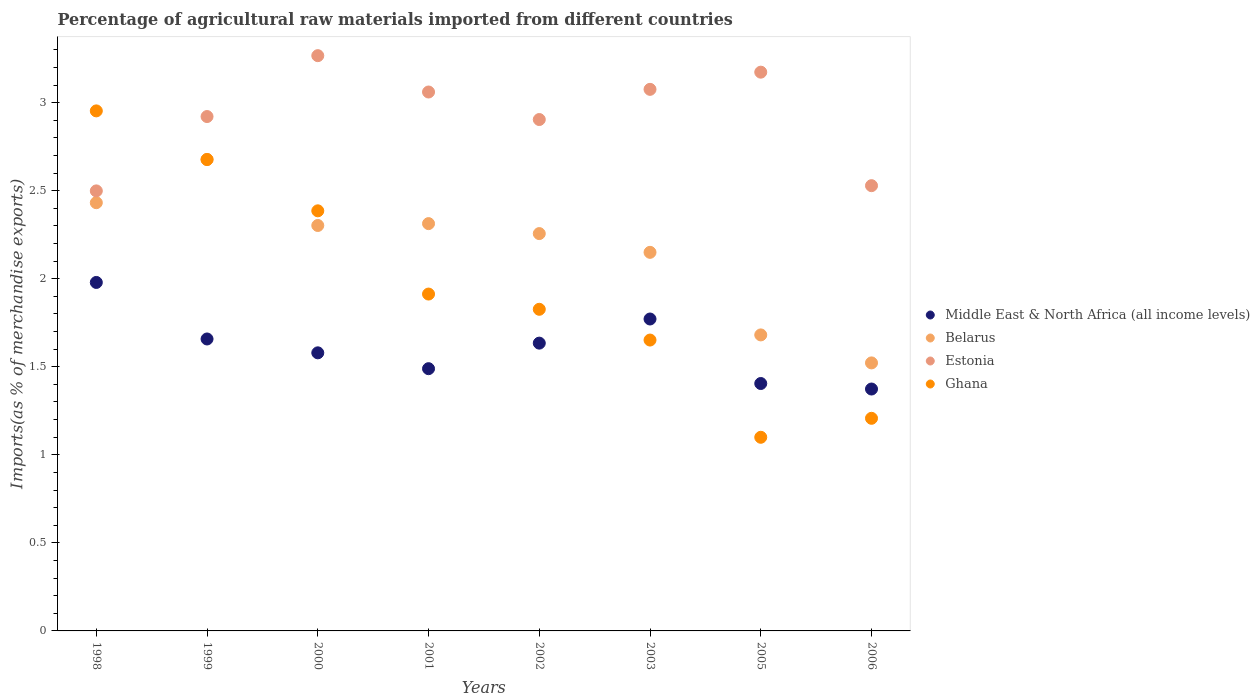How many different coloured dotlines are there?
Make the answer very short. 4. Is the number of dotlines equal to the number of legend labels?
Give a very brief answer. Yes. What is the percentage of imports to different countries in Ghana in 2001?
Keep it short and to the point. 1.91. Across all years, what is the maximum percentage of imports to different countries in Belarus?
Offer a terse response. 2.68. Across all years, what is the minimum percentage of imports to different countries in Estonia?
Make the answer very short. 2.5. In which year was the percentage of imports to different countries in Middle East & North Africa (all income levels) maximum?
Your response must be concise. 1998. In which year was the percentage of imports to different countries in Belarus minimum?
Give a very brief answer. 2006. What is the total percentage of imports to different countries in Ghana in the graph?
Ensure brevity in your answer.  15.71. What is the difference between the percentage of imports to different countries in Middle East & North Africa (all income levels) in 1998 and that in 2003?
Give a very brief answer. 0.21. What is the difference between the percentage of imports to different countries in Middle East & North Africa (all income levels) in 1999 and the percentage of imports to different countries in Ghana in 2000?
Make the answer very short. -0.73. What is the average percentage of imports to different countries in Belarus per year?
Provide a succinct answer. 2.17. In the year 2002, what is the difference between the percentage of imports to different countries in Ghana and percentage of imports to different countries in Estonia?
Your answer should be compact. -1.08. What is the ratio of the percentage of imports to different countries in Belarus in 2003 to that in 2006?
Offer a terse response. 1.41. What is the difference between the highest and the second highest percentage of imports to different countries in Ghana?
Provide a short and direct response. 0.28. What is the difference between the highest and the lowest percentage of imports to different countries in Belarus?
Your response must be concise. 1.16. In how many years, is the percentage of imports to different countries in Ghana greater than the average percentage of imports to different countries in Ghana taken over all years?
Your answer should be very brief. 3. Is the percentage of imports to different countries in Estonia strictly greater than the percentage of imports to different countries in Ghana over the years?
Make the answer very short. No. Is the percentage of imports to different countries in Belarus strictly less than the percentage of imports to different countries in Ghana over the years?
Your response must be concise. No. How many dotlines are there?
Your response must be concise. 4. What is the difference between two consecutive major ticks on the Y-axis?
Your answer should be compact. 0.5. Are the values on the major ticks of Y-axis written in scientific E-notation?
Provide a succinct answer. No. Where does the legend appear in the graph?
Give a very brief answer. Center right. What is the title of the graph?
Keep it short and to the point. Percentage of agricultural raw materials imported from different countries. Does "Oman" appear as one of the legend labels in the graph?
Your answer should be very brief. No. What is the label or title of the X-axis?
Provide a short and direct response. Years. What is the label or title of the Y-axis?
Offer a very short reply. Imports(as % of merchandise exports). What is the Imports(as % of merchandise exports) in Middle East & North Africa (all income levels) in 1998?
Offer a terse response. 1.98. What is the Imports(as % of merchandise exports) of Belarus in 1998?
Your answer should be very brief. 2.43. What is the Imports(as % of merchandise exports) in Estonia in 1998?
Offer a terse response. 2.5. What is the Imports(as % of merchandise exports) of Ghana in 1998?
Your answer should be very brief. 2.95. What is the Imports(as % of merchandise exports) in Middle East & North Africa (all income levels) in 1999?
Ensure brevity in your answer.  1.66. What is the Imports(as % of merchandise exports) in Belarus in 1999?
Make the answer very short. 2.68. What is the Imports(as % of merchandise exports) of Estonia in 1999?
Your answer should be compact. 2.92. What is the Imports(as % of merchandise exports) in Ghana in 1999?
Ensure brevity in your answer.  2.68. What is the Imports(as % of merchandise exports) in Middle East & North Africa (all income levels) in 2000?
Offer a terse response. 1.58. What is the Imports(as % of merchandise exports) in Belarus in 2000?
Your answer should be compact. 2.3. What is the Imports(as % of merchandise exports) of Estonia in 2000?
Your answer should be compact. 3.27. What is the Imports(as % of merchandise exports) in Ghana in 2000?
Keep it short and to the point. 2.39. What is the Imports(as % of merchandise exports) in Middle East & North Africa (all income levels) in 2001?
Provide a short and direct response. 1.49. What is the Imports(as % of merchandise exports) of Belarus in 2001?
Provide a succinct answer. 2.31. What is the Imports(as % of merchandise exports) in Estonia in 2001?
Make the answer very short. 3.06. What is the Imports(as % of merchandise exports) in Ghana in 2001?
Your response must be concise. 1.91. What is the Imports(as % of merchandise exports) in Middle East & North Africa (all income levels) in 2002?
Ensure brevity in your answer.  1.63. What is the Imports(as % of merchandise exports) of Belarus in 2002?
Keep it short and to the point. 2.26. What is the Imports(as % of merchandise exports) in Estonia in 2002?
Your answer should be compact. 2.9. What is the Imports(as % of merchandise exports) of Ghana in 2002?
Your response must be concise. 1.83. What is the Imports(as % of merchandise exports) of Middle East & North Africa (all income levels) in 2003?
Offer a very short reply. 1.77. What is the Imports(as % of merchandise exports) in Belarus in 2003?
Keep it short and to the point. 2.15. What is the Imports(as % of merchandise exports) in Estonia in 2003?
Ensure brevity in your answer.  3.08. What is the Imports(as % of merchandise exports) in Ghana in 2003?
Give a very brief answer. 1.65. What is the Imports(as % of merchandise exports) of Middle East & North Africa (all income levels) in 2005?
Provide a succinct answer. 1.4. What is the Imports(as % of merchandise exports) in Belarus in 2005?
Offer a terse response. 1.68. What is the Imports(as % of merchandise exports) of Estonia in 2005?
Your answer should be compact. 3.17. What is the Imports(as % of merchandise exports) of Ghana in 2005?
Keep it short and to the point. 1.1. What is the Imports(as % of merchandise exports) of Middle East & North Africa (all income levels) in 2006?
Ensure brevity in your answer.  1.37. What is the Imports(as % of merchandise exports) in Belarus in 2006?
Your response must be concise. 1.52. What is the Imports(as % of merchandise exports) of Estonia in 2006?
Your answer should be very brief. 2.53. What is the Imports(as % of merchandise exports) in Ghana in 2006?
Your answer should be very brief. 1.21. Across all years, what is the maximum Imports(as % of merchandise exports) in Middle East & North Africa (all income levels)?
Your answer should be very brief. 1.98. Across all years, what is the maximum Imports(as % of merchandise exports) in Belarus?
Make the answer very short. 2.68. Across all years, what is the maximum Imports(as % of merchandise exports) in Estonia?
Provide a short and direct response. 3.27. Across all years, what is the maximum Imports(as % of merchandise exports) of Ghana?
Make the answer very short. 2.95. Across all years, what is the minimum Imports(as % of merchandise exports) in Middle East & North Africa (all income levels)?
Your response must be concise. 1.37. Across all years, what is the minimum Imports(as % of merchandise exports) of Belarus?
Give a very brief answer. 1.52. Across all years, what is the minimum Imports(as % of merchandise exports) in Estonia?
Keep it short and to the point. 2.5. Across all years, what is the minimum Imports(as % of merchandise exports) of Ghana?
Ensure brevity in your answer.  1.1. What is the total Imports(as % of merchandise exports) of Middle East & North Africa (all income levels) in the graph?
Make the answer very short. 12.89. What is the total Imports(as % of merchandise exports) in Belarus in the graph?
Your answer should be very brief. 17.33. What is the total Imports(as % of merchandise exports) of Estonia in the graph?
Offer a very short reply. 23.43. What is the total Imports(as % of merchandise exports) in Ghana in the graph?
Your response must be concise. 15.71. What is the difference between the Imports(as % of merchandise exports) in Middle East & North Africa (all income levels) in 1998 and that in 1999?
Offer a very short reply. 0.32. What is the difference between the Imports(as % of merchandise exports) in Belarus in 1998 and that in 1999?
Provide a short and direct response. -0.25. What is the difference between the Imports(as % of merchandise exports) of Estonia in 1998 and that in 1999?
Your answer should be compact. -0.42. What is the difference between the Imports(as % of merchandise exports) of Ghana in 1998 and that in 1999?
Your answer should be compact. 0.28. What is the difference between the Imports(as % of merchandise exports) of Middle East & North Africa (all income levels) in 1998 and that in 2000?
Your answer should be very brief. 0.4. What is the difference between the Imports(as % of merchandise exports) in Belarus in 1998 and that in 2000?
Offer a very short reply. 0.13. What is the difference between the Imports(as % of merchandise exports) in Estonia in 1998 and that in 2000?
Your answer should be very brief. -0.77. What is the difference between the Imports(as % of merchandise exports) in Ghana in 1998 and that in 2000?
Give a very brief answer. 0.57. What is the difference between the Imports(as % of merchandise exports) in Middle East & North Africa (all income levels) in 1998 and that in 2001?
Provide a short and direct response. 0.49. What is the difference between the Imports(as % of merchandise exports) of Belarus in 1998 and that in 2001?
Your response must be concise. 0.12. What is the difference between the Imports(as % of merchandise exports) in Estonia in 1998 and that in 2001?
Your answer should be compact. -0.56. What is the difference between the Imports(as % of merchandise exports) in Ghana in 1998 and that in 2001?
Ensure brevity in your answer.  1.04. What is the difference between the Imports(as % of merchandise exports) of Middle East & North Africa (all income levels) in 1998 and that in 2002?
Make the answer very short. 0.34. What is the difference between the Imports(as % of merchandise exports) in Belarus in 1998 and that in 2002?
Provide a short and direct response. 0.18. What is the difference between the Imports(as % of merchandise exports) in Estonia in 1998 and that in 2002?
Provide a succinct answer. -0.41. What is the difference between the Imports(as % of merchandise exports) of Ghana in 1998 and that in 2002?
Your response must be concise. 1.13. What is the difference between the Imports(as % of merchandise exports) in Middle East & North Africa (all income levels) in 1998 and that in 2003?
Provide a short and direct response. 0.21. What is the difference between the Imports(as % of merchandise exports) in Belarus in 1998 and that in 2003?
Keep it short and to the point. 0.28. What is the difference between the Imports(as % of merchandise exports) of Estonia in 1998 and that in 2003?
Your answer should be compact. -0.58. What is the difference between the Imports(as % of merchandise exports) in Ghana in 1998 and that in 2003?
Your answer should be very brief. 1.3. What is the difference between the Imports(as % of merchandise exports) of Middle East & North Africa (all income levels) in 1998 and that in 2005?
Provide a succinct answer. 0.57. What is the difference between the Imports(as % of merchandise exports) of Belarus in 1998 and that in 2005?
Ensure brevity in your answer.  0.75. What is the difference between the Imports(as % of merchandise exports) in Estonia in 1998 and that in 2005?
Your answer should be compact. -0.67. What is the difference between the Imports(as % of merchandise exports) in Ghana in 1998 and that in 2005?
Your response must be concise. 1.85. What is the difference between the Imports(as % of merchandise exports) of Middle East & North Africa (all income levels) in 1998 and that in 2006?
Give a very brief answer. 0.61. What is the difference between the Imports(as % of merchandise exports) of Belarus in 1998 and that in 2006?
Give a very brief answer. 0.91. What is the difference between the Imports(as % of merchandise exports) of Estonia in 1998 and that in 2006?
Offer a very short reply. -0.03. What is the difference between the Imports(as % of merchandise exports) of Ghana in 1998 and that in 2006?
Ensure brevity in your answer.  1.75. What is the difference between the Imports(as % of merchandise exports) of Middle East & North Africa (all income levels) in 1999 and that in 2000?
Give a very brief answer. 0.08. What is the difference between the Imports(as % of merchandise exports) in Belarus in 1999 and that in 2000?
Give a very brief answer. 0.38. What is the difference between the Imports(as % of merchandise exports) in Estonia in 1999 and that in 2000?
Make the answer very short. -0.35. What is the difference between the Imports(as % of merchandise exports) of Ghana in 1999 and that in 2000?
Keep it short and to the point. 0.29. What is the difference between the Imports(as % of merchandise exports) of Middle East & North Africa (all income levels) in 1999 and that in 2001?
Offer a very short reply. 0.17. What is the difference between the Imports(as % of merchandise exports) in Belarus in 1999 and that in 2001?
Make the answer very short. 0.36. What is the difference between the Imports(as % of merchandise exports) in Estonia in 1999 and that in 2001?
Your response must be concise. -0.14. What is the difference between the Imports(as % of merchandise exports) in Ghana in 1999 and that in 2001?
Keep it short and to the point. 0.76. What is the difference between the Imports(as % of merchandise exports) in Middle East & North Africa (all income levels) in 1999 and that in 2002?
Your answer should be compact. 0.02. What is the difference between the Imports(as % of merchandise exports) in Belarus in 1999 and that in 2002?
Make the answer very short. 0.42. What is the difference between the Imports(as % of merchandise exports) of Estonia in 1999 and that in 2002?
Your answer should be very brief. 0.02. What is the difference between the Imports(as % of merchandise exports) in Ghana in 1999 and that in 2002?
Your answer should be compact. 0.85. What is the difference between the Imports(as % of merchandise exports) of Middle East & North Africa (all income levels) in 1999 and that in 2003?
Offer a terse response. -0.11. What is the difference between the Imports(as % of merchandise exports) of Belarus in 1999 and that in 2003?
Provide a short and direct response. 0.53. What is the difference between the Imports(as % of merchandise exports) in Estonia in 1999 and that in 2003?
Make the answer very short. -0.15. What is the difference between the Imports(as % of merchandise exports) of Ghana in 1999 and that in 2003?
Give a very brief answer. 1.03. What is the difference between the Imports(as % of merchandise exports) in Middle East & North Africa (all income levels) in 1999 and that in 2005?
Make the answer very short. 0.25. What is the difference between the Imports(as % of merchandise exports) of Estonia in 1999 and that in 2005?
Offer a very short reply. -0.25. What is the difference between the Imports(as % of merchandise exports) in Ghana in 1999 and that in 2005?
Ensure brevity in your answer.  1.58. What is the difference between the Imports(as % of merchandise exports) in Middle East & North Africa (all income levels) in 1999 and that in 2006?
Provide a short and direct response. 0.28. What is the difference between the Imports(as % of merchandise exports) of Belarus in 1999 and that in 2006?
Make the answer very short. 1.16. What is the difference between the Imports(as % of merchandise exports) in Estonia in 1999 and that in 2006?
Provide a short and direct response. 0.39. What is the difference between the Imports(as % of merchandise exports) in Ghana in 1999 and that in 2006?
Give a very brief answer. 1.47. What is the difference between the Imports(as % of merchandise exports) in Middle East & North Africa (all income levels) in 2000 and that in 2001?
Offer a terse response. 0.09. What is the difference between the Imports(as % of merchandise exports) in Belarus in 2000 and that in 2001?
Provide a succinct answer. -0.01. What is the difference between the Imports(as % of merchandise exports) of Estonia in 2000 and that in 2001?
Your answer should be compact. 0.21. What is the difference between the Imports(as % of merchandise exports) in Ghana in 2000 and that in 2001?
Offer a terse response. 0.47. What is the difference between the Imports(as % of merchandise exports) of Middle East & North Africa (all income levels) in 2000 and that in 2002?
Offer a terse response. -0.06. What is the difference between the Imports(as % of merchandise exports) in Belarus in 2000 and that in 2002?
Make the answer very short. 0.05. What is the difference between the Imports(as % of merchandise exports) of Estonia in 2000 and that in 2002?
Offer a terse response. 0.36. What is the difference between the Imports(as % of merchandise exports) in Ghana in 2000 and that in 2002?
Your answer should be compact. 0.56. What is the difference between the Imports(as % of merchandise exports) in Middle East & North Africa (all income levels) in 2000 and that in 2003?
Your answer should be very brief. -0.19. What is the difference between the Imports(as % of merchandise exports) of Belarus in 2000 and that in 2003?
Make the answer very short. 0.15. What is the difference between the Imports(as % of merchandise exports) in Estonia in 2000 and that in 2003?
Provide a succinct answer. 0.19. What is the difference between the Imports(as % of merchandise exports) in Ghana in 2000 and that in 2003?
Provide a succinct answer. 0.73. What is the difference between the Imports(as % of merchandise exports) in Middle East & North Africa (all income levels) in 2000 and that in 2005?
Ensure brevity in your answer.  0.17. What is the difference between the Imports(as % of merchandise exports) of Belarus in 2000 and that in 2005?
Offer a terse response. 0.62. What is the difference between the Imports(as % of merchandise exports) of Estonia in 2000 and that in 2005?
Your answer should be compact. 0.09. What is the difference between the Imports(as % of merchandise exports) in Ghana in 2000 and that in 2005?
Your answer should be compact. 1.29. What is the difference between the Imports(as % of merchandise exports) in Middle East & North Africa (all income levels) in 2000 and that in 2006?
Offer a terse response. 0.21. What is the difference between the Imports(as % of merchandise exports) of Belarus in 2000 and that in 2006?
Ensure brevity in your answer.  0.78. What is the difference between the Imports(as % of merchandise exports) of Estonia in 2000 and that in 2006?
Offer a terse response. 0.74. What is the difference between the Imports(as % of merchandise exports) in Ghana in 2000 and that in 2006?
Offer a terse response. 1.18. What is the difference between the Imports(as % of merchandise exports) in Middle East & North Africa (all income levels) in 2001 and that in 2002?
Offer a terse response. -0.15. What is the difference between the Imports(as % of merchandise exports) of Belarus in 2001 and that in 2002?
Offer a terse response. 0.06. What is the difference between the Imports(as % of merchandise exports) in Estonia in 2001 and that in 2002?
Your answer should be compact. 0.16. What is the difference between the Imports(as % of merchandise exports) in Ghana in 2001 and that in 2002?
Your answer should be compact. 0.09. What is the difference between the Imports(as % of merchandise exports) of Middle East & North Africa (all income levels) in 2001 and that in 2003?
Your answer should be compact. -0.28. What is the difference between the Imports(as % of merchandise exports) in Belarus in 2001 and that in 2003?
Your answer should be compact. 0.16. What is the difference between the Imports(as % of merchandise exports) in Estonia in 2001 and that in 2003?
Your answer should be compact. -0.02. What is the difference between the Imports(as % of merchandise exports) in Ghana in 2001 and that in 2003?
Make the answer very short. 0.26. What is the difference between the Imports(as % of merchandise exports) of Middle East & North Africa (all income levels) in 2001 and that in 2005?
Ensure brevity in your answer.  0.08. What is the difference between the Imports(as % of merchandise exports) in Belarus in 2001 and that in 2005?
Your answer should be compact. 0.63. What is the difference between the Imports(as % of merchandise exports) of Estonia in 2001 and that in 2005?
Offer a terse response. -0.11. What is the difference between the Imports(as % of merchandise exports) in Ghana in 2001 and that in 2005?
Offer a terse response. 0.81. What is the difference between the Imports(as % of merchandise exports) in Middle East & North Africa (all income levels) in 2001 and that in 2006?
Make the answer very short. 0.12. What is the difference between the Imports(as % of merchandise exports) of Belarus in 2001 and that in 2006?
Make the answer very short. 0.79. What is the difference between the Imports(as % of merchandise exports) in Estonia in 2001 and that in 2006?
Your response must be concise. 0.53. What is the difference between the Imports(as % of merchandise exports) of Ghana in 2001 and that in 2006?
Your answer should be very brief. 0.71. What is the difference between the Imports(as % of merchandise exports) of Middle East & North Africa (all income levels) in 2002 and that in 2003?
Provide a short and direct response. -0.14. What is the difference between the Imports(as % of merchandise exports) in Belarus in 2002 and that in 2003?
Your answer should be very brief. 0.11. What is the difference between the Imports(as % of merchandise exports) in Estonia in 2002 and that in 2003?
Make the answer very short. -0.17. What is the difference between the Imports(as % of merchandise exports) of Ghana in 2002 and that in 2003?
Offer a terse response. 0.17. What is the difference between the Imports(as % of merchandise exports) of Middle East & North Africa (all income levels) in 2002 and that in 2005?
Provide a short and direct response. 0.23. What is the difference between the Imports(as % of merchandise exports) in Belarus in 2002 and that in 2005?
Your answer should be compact. 0.58. What is the difference between the Imports(as % of merchandise exports) in Estonia in 2002 and that in 2005?
Your response must be concise. -0.27. What is the difference between the Imports(as % of merchandise exports) in Ghana in 2002 and that in 2005?
Your answer should be very brief. 0.73. What is the difference between the Imports(as % of merchandise exports) in Middle East & North Africa (all income levels) in 2002 and that in 2006?
Offer a terse response. 0.26. What is the difference between the Imports(as % of merchandise exports) in Belarus in 2002 and that in 2006?
Your response must be concise. 0.73. What is the difference between the Imports(as % of merchandise exports) in Estonia in 2002 and that in 2006?
Your answer should be very brief. 0.38. What is the difference between the Imports(as % of merchandise exports) in Ghana in 2002 and that in 2006?
Your answer should be compact. 0.62. What is the difference between the Imports(as % of merchandise exports) of Middle East & North Africa (all income levels) in 2003 and that in 2005?
Ensure brevity in your answer.  0.37. What is the difference between the Imports(as % of merchandise exports) in Belarus in 2003 and that in 2005?
Your response must be concise. 0.47. What is the difference between the Imports(as % of merchandise exports) of Estonia in 2003 and that in 2005?
Provide a succinct answer. -0.1. What is the difference between the Imports(as % of merchandise exports) in Ghana in 2003 and that in 2005?
Offer a terse response. 0.55. What is the difference between the Imports(as % of merchandise exports) in Middle East & North Africa (all income levels) in 2003 and that in 2006?
Your response must be concise. 0.4. What is the difference between the Imports(as % of merchandise exports) of Belarus in 2003 and that in 2006?
Your answer should be very brief. 0.63. What is the difference between the Imports(as % of merchandise exports) in Estonia in 2003 and that in 2006?
Offer a terse response. 0.55. What is the difference between the Imports(as % of merchandise exports) in Ghana in 2003 and that in 2006?
Offer a very short reply. 0.44. What is the difference between the Imports(as % of merchandise exports) in Middle East & North Africa (all income levels) in 2005 and that in 2006?
Your answer should be very brief. 0.03. What is the difference between the Imports(as % of merchandise exports) in Belarus in 2005 and that in 2006?
Your response must be concise. 0.16. What is the difference between the Imports(as % of merchandise exports) of Estonia in 2005 and that in 2006?
Provide a short and direct response. 0.64. What is the difference between the Imports(as % of merchandise exports) in Ghana in 2005 and that in 2006?
Your answer should be very brief. -0.11. What is the difference between the Imports(as % of merchandise exports) of Middle East & North Africa (all income levels) in 1998 and the Imports(as % of merchandise exports) of Belarus in 1999?
Keep it short and to the point. -0.7. What is the difference between the Imports(as % of merchandise exports) in Middle East & North Africa (all income levels) in 1998 and the Imports(as % of merchandise exports) in Estonia in 1999?
Provide a succinct answer. -0.94. What is the difference between the Imports(as % of merchandise exports) of Middle East & North Africa (all income levels) in 1998 and the Imports(as % of merchandise exports) of Ghana in 1999?
Ensure brevity in your answer.  -0.7. What is the difference between the Imports(as % of merchandise exports) of Belarus in 1998 and the Imports(as % of merchandise exports) of Estonia in 1999?
Ensure brevity in your answer.  -0.49. What is the difference between the Imports(as % of merchandise exports) of Belarus in 1998 and the Imports(as % of merchandise exports) of Ghana in 1999?
Make the answer very short. -0.25. What is the difference between the Imports(as % of merchandise exports) in Estonia in 1998 and the Imports(as % of merchandise exports) in Ghana in 1999?
Your answer should be compact. -0.18. What is the difference between the Imports(as % of merchandise exports) in Middle East & North Africa (all income levels) in 1998 and the Imports(as % of merchandise exports) in Belarus in 2000?
Keep it short and to the point. -0.32. What is the difference between the Imports(as % of merchandise exports) in Middle East & North Africa (all income levels) in 1998 and the Imports(as % of merchandise exports) in Estonia in 2000?
Ensure brevity in your answer.  -1.29. What is the difference between the Imports(as % of merchandise exports) of Middle East & North Africa (all income levels) in 1998 and the Imports(as % of merchandise exports) of Ghana in 2000?
Your answer should be compact. -0.41. What is the difference between the Imports(as % of merchandise exports) in Belarus in 1998 and the Imports(as % of merchandise exports) in Estonia in 2000?
Give a very brief answer. -0.83. What is the difference between the Imports(as % of merchandise exports) in Belarus in 1998 and the Imports(as % of merchandise exports) in Ghana in 2000?
Your answer should be compact. 0.05. What is the difference between the Imports(as % of merchandise exports) of Estonia in 1998 and the Imports(as % of merchandise exports) of Ghana in 2000?
Give a very brief answer. 0.11. What is the difference between the Imports(as % of merchandise exports) of Middle East & North Africa (all income levels) in 1998 and the Imports(as % of merchandise exports) of Belarus in 2001?
Make the answer very short. -0.33. What is the difference between the Imports(as % of merchandise exports) of Middle East & North Africa (all income levels) in 1998 and the Imports(as % of merchandise exports) of Estonia in 2001?
Your answer should be very brief. -1.08. What is the difference between the Imports(as % of merchandise exports) in Middle East & North Africa (all income levels) in 1998 and the Imports(as % of merchandise exports) in Ghana in 2001?
Give a very brief answer. 0.07. What is the difference between the Imports(as % of merchandise exports) in Belarus in 1998 and the Imports(as % of merchandise exports) in Estonia in 2001?
Offer a very short reply. -0.63. What is the difference between the Imports(as % of merchandise exports) in Belarus in 1998 and the Imports(as % of merchandise exports) in Ghana in 2001?
Ensure brevity in your answer.  0.52. What is the difference between the Imports(as % of merchandise exports) of Estonia in 1998 and the Imports(as % of merchandise exports) of Ghana in 2001?
Offer a very short reply. 0.59. What is the difference between the Imports(as % of merchandise exports) of Middle East & North Africa (all income levels) in 1998 and the Imports(as % of merchandise exports) of Belarus in 2002?
Ensure brevity in your answer.  -0.28. What is the difference between the Imports(as % of merchandise exports) in Middle East & North Africa (all income levels) in 1998 and the Imports(as % of merchandise exports) in Estonia in 2002?
Your answer should be compact. -0.93. What is the difference between the Imports(as % of merchandise exports) of Middle East & North Africa (all income levels) in 1998 and the Imports(as % of merchandise exports) of Ghana in 2002?
Offer a terse response. 0.15. What is the difference between the Imports(as % of merchandise exports) of Belarus in 1998 and the Imports(as % of merchandise exports) of Estonia in 2002?
Your response must be concise. -0.47. What is the difference between the Imports(as % of merchandise exports) in Belarus in 1998 and the Imports(as % of merchandise exports) in Ghana in 2002?
Provide a succinct answer. 0.61. What is the difference between the Imports(as % of merchandise exports) in Estonia in 1998 and the Imports(as % of merchandise exports) in Ghana in 2002?
Your answer should be very brief. 0.67. What is the difference between the Imports(as % of merchandise exports) in Middle East & North Africa (all income levels) in 1998 and the Imports(as % of merchandise exports) in Belarus in 2003?
Provide a short and direct response. -0.17. What is the difference between the Imports(as % of merchandise exports) in Middle East & North Africa (all income levels) in 1998 and the Imports(as % of merchandise exports) in Estonia in 2003?
Provide a succinct answer. -1.1. What is the difference between the Imports(as % of merchandise exports) of Middle East & North Africa (all income levels) in 1998 and the Imports(as % of merchandise exports) of Ghana in 2003?
Ensure brevity in your answer.  0.33. What is the difference between the Imports(as % of merchandise exports) of Belarus in 1998 and the Imports(as % of merchandise exports) of Estonia in 2003?
Provide a succinct answer. -0.64. What is the difference between the Imports(as % of merchandise exports) of Belarus in 1998 and the Imports(as % of merchandise exports) of Ghana in 2003?
Your answer should be compact. 0.78. What is the difference between the Imports(as % of merchandise exports) of Estonia in 1998 and the Imports(as % of merchandise exports) of Ghana in 2003?
Make the answer very short. 0.85. What is the difference between the Imports(as % of merchandise exports) in Middle East & North Africa (all income levels) in 1998 and the Imports(as % of merchandise exports) in Belarus in 2005?
Provide a succinct answer. 0.3. What is the difference between the Imports(as % of merchandise exports) of Middle East & North Africa (all income levels) in 1998 and the Imports(as % of merchandise exports) of Estonia in 2005?
Ensure brevity in your answer.  -1.19. What is the difference between the Imports(as % of merchandise exports) in Middle East & North Africa (all income levels) in 1998 and the Imports(as % of merchandise exports) in Ghana in 2005?
Keep it short and to the point. 0.88. What is the difference between the Imports(as % of merchandise exports) in Belarus in 1998 and the Imports(as % of merchandise exports) in Estonia in 2005?
Give a very brief answer. -0.74. What is the difference between the Imports(as % of merchandise exports) in Belarus in 1998 and the Imports(as % of merchandise exports) in Ghana in 2005?
Offer a very short reply. 1.33. What is the difference between the Imports(as % of merchandise exports) of Estonia in 1998 and the Imports(as % of merchandise exports) of Ghana in 2005?
Offer a terse response. 1.4. What is the difference between the Imports(as % of merchandise exports) of Middle East & North Africa (all income levels) in 1998 and the Imports(as % of merchandise exports) of Belarus in 2006?
Your answer should be compact. 0.46. What is the difference between the Imports(as % of merchandise exports) in Middle East & North Africa (all income levels) in 1998 and the Imports(as % of merchandise exports) in Estonia in 2006?
Offer a terse response. -0.55. What is the difference between the Imports(as % of merchandise exports) in Middle East & North Africa (all income levels) in 1998 and the Imports(as % of merchandise exports) in Ghana in 2006?
Keep it short and to the point. 0.77. What is the difference between the Imports(as % of merchandise exports) of Belarus in 1998 and the Imports(as % of merchandise exports) of Estonia in 2006?
Offer a very short reply. -0.1. What is the difference between the Imports(as % of merchandise exports) of Belarus in 1998 and the Imports(as % of merchandise exports) of Ghana in 2006?
Keep it short and to the point. 1.22. What is the difference between the Imports(as % of merchandise exports) in Estonia in 1998 and the Imports(as % of merchandise exports) in Ghana in 2006?
Provide a short and direct response. 1.29. What is the difference between the Imports(as % of merchandise exports) of Middle East & North Africa (all income levels) in 1999 and the Imports(as % of merchandise exports) of Belarus in 2000?
Ensure brevity in your answer.  -0.64. What is the difference between the Imports(as % of merchandise exports) in Middle East & North Africa (all income levels) in 1999 and the Imports(as % of merchandise exports) in Estonia in 2000?
Keep it short and to the point. -1.61. What is the difference between the Imports(as % of merchandise exports) in Middle East & North Africa (all income levels) in 1999 and the Imports(as % of merchandise exports) in Ghana in 2000?
Keep it short and to the point. -0.73. What is the difference between the Imports(as % of merchandise exports) in Belarus in 1999 and the Imports(as % of merchandise exports) in Estonia in 2000?
Ensure brevity in your answer.  -0.59. What is the difference between the Imports(as % of merchandise exports) of Belarus in 1999 and the Imports(as % of merchandise exports) of Ghana in 2000?
Provide a succinct answer. 0.29. What is the difference between the Imports(as % of merchandise exports) in Estonia in 1999 and the Imports(as % of merchandise exports) in Ghana in 2000?
Offer a terse response. 0.54. What is the difference between the Imports(as % of merchandise exports) of Middle East & North Africa (all income levels) in 1999 and the Imports(as % of merchandise exports) of Belarus in 2001?
Your answer should be compact. -0.66. What is the difference between the Imports(as % of merchandise exports) of Middle East & North Africa (all income levels) in 1999 and the Imports(as % of merchandise exports) of Estonia in 2001?
Your response must be concise. -1.4. What is the difference between the Imports(as % of merchandise exports) of Middle East & North Africa (all income levels) in 1999 and the Imports(as % of merchandise exports) of Ghana in 2001?
Keep it short and to the point. -0.26. What is the difference between the Imports(as % of merchandise exports) of Belarus in 1999 and the Imports(as % of merchandise exports) of Estonia in 2001?
Keep it short and to the point. -0.38. What is the difference between the Imports(as % of merchandise exports) in Belarus in 1999 and the Imports(as % of merchandise exports) in Ghana in 2001?
Make the answer very short. 0.76. What is the difference between the Imports(as % of merchandise exports) of Middle East & North Africa (all income levels) in 1999 and the Imports(as % of merchandise exports) of Belarus in 2002?
Give a very brief answer. -0.6. What is the difference between the Imports(as % of merchandise exports) of Middle East & North Africa (all income levels) in 1999 and the Imports(as % of merchandise exports) of Estonia in 2002?
Keep it short and to the point. -1.25. What is the difference between the Imports(as % of merchandise exports) in Middle East & North Africa (all income levels) in 1999 and the Imports(as % of merchandise exports) in Ghana in 2002?
Give a very brief answer. -0.17. What is the difference between the Imports(as % of merchandise exports) in Belarus in 1999 and the Imports(as % of merchandise exports) in Estonia in 2002?
Your response must be concise. -0.23. What is the difference between the Imports(as % of merchandise exports) in Belarus in 1999 and the Imports(as % of merchandise exports) in Ghana in 2002?
Provide a succinct answer. 0.85. What is the difference between the Imports(as % of merchandise exports) in Estonia in 1999 and the Imports(as % of merchandise exports) in Ghana in 2002?
Provide a short and direct response. 1.09. What is the difference between the Imports(as % of merchandise exports) of Middle East & North Africa (all income levels) in 1999 and the Imports(as % of merchandise exports) of Belarus in 2003?
Make the answer very short. -0.49. What is the difference between the Imports(as % of merchandise exports) in Middle East & North Africa (all income levels) in 1999 and the Imports(as % of merchandise exports) in Estonia in 2003?
Offer a terse response. -1.42. What is the difference between the Imports(as % of merchandise exports) of Middle East & North Africa (all income levels) in 1999 and the Imports(as % of merchandise exports) of Ghana in 2003?
Your response must be concise. 0.01. What is the difference between the Imports(as % of merchandise exports) of Belarus in 1999 and the Imports(as % of merchandise exports) of Estonia in 2003?
Make the answer very short. -0.4. What is the difference between the Imports(as % of merchandise exports) in Belarus in 1999 and the Imports(as % of merchandise exports) in Ghana in 2003?
Your response must be concise. 1.03. What is the difference between the Imports(as % of merchandise exports) of Estonia in 1999 and the Imports(as % of merchandise exports) of Ghana in 2003?
Keep it short and to the point. 1.27. What is the difference between the Imports(as % of merchandise exports) in Middle East & North Africa (all income levels) in 1999 and the Imports(as % of merchandise exports) in Belarus in 2005?
Offer a terse response. -0.02. What is the difference between the Imports(as % of merchandise exports) of Middle East & North Africa (all income levels) in 1999 and the Imports(as % of merchandise exports) of Estonia in 2005?
Your answer should be very brief. -1.52. What is the difference between the Imports(as % of merchandise exports) in Middle East & North Africa (all income levels) in 1999 and the Imports(as % of merchandise exports) in Ghana in 2005?
Your response must be concise. 0.56. What is the difference between the Imports(as % of merchandise exports) of Belarus in 1999 and the Imports(as % of merchandise exports) of Estonia in 2005?
Your answer should be very brief. -0.5. What is the difference between the Imports(as % of merchandise exports) in Belarus in 1999 and the Imports(as % of merchandise exports) in Ghana in 2005?
Provide a succinct answer. 1.58. What is the difference between the Imports(as % of merchandise exports) in Estonia in 1999 and the Imports(as % of merchandise exports) in Ghana in 2005?
Give a very brief answer. 1.82. What is the difference between the Imports(as % of merchandise exports) of Middle East & North Africa (all income levels) in 1999 and the Imports(as % of merchandise exports) of Belarus in 2006?
Ensure brevity in your answer.  0.14. What is the difference between the Imports(as % of merchandise exports) of Middle East & North Africa (all income levels) in 1999 and the Imports(as % of merchandise exports) of Estonia in 2006?
Provide a short and direct response. -0.87. What is the difference between the Imports(as % of merchandise exports) in Middle East & North Africa (all income levels) in 1999 and the Imports(as % of merchandise exports) in Ghana in 2006?
Your response must be concise. 0.45. What is the difference between the Imports(as % of merchandise exports) in Belarus in 1999 and the Imports(as % of merchandise exports) in Estonia in 2006?
Your response must be concise. 0.15. What is the difference between the Imports(as % of merchandise exports) of Belarus in 1999 and the Imports(as % of merchandise exports) of Ghana in 2006?
Make the answer very short. 1.47. What is the difference between the Imports(as % of merchandise exports) in Estonia in 1999 and the Imports(as % of merchandise exports) in Ghana in 2006?
Give a very brief answer. 1.71. What is the difference between the Imports(as % of merchandise exports) in Middle East & North Africa (all income levels) in 2000 and the Imports(as % of merchandise exports) in Belarus in 2001?
Offer a terse response. -0.73. What is the difference between the Imports(as % of merchandise exports) of Middle East & North Africa (all income levels) in 2000 and the Imports(as % of merchandise exports) of Estonia in 2001?
Offer a very short reply. -1.48. What is the difference between the Imports(as % of merchandise exports) in Middle East & North Africa (all income levels) in 2000 and the Imports(as % of merchandise exports) in Ghana in 2001?
Your answer should be compact. -0.33. What is the difference between the Imports(as % of merchandise exports) of Belarus in 2000 and the Imports(as % of merchandise exports) of Estonia in 2001?
Offer a very short reply. -0.76. What is the difference between the Imports(as % of merchandise exports) in Belarus in 2000 and the Imports(as % of merchandise exports) in Ghana in 2001?
Your answer should be very brief. 0.39. What is the difference between the Imports(as % of merchandise exports) of Estonia in 2000 and the Imports(as % of merchandise exports) of Ghana in 2001?
Your response must be concise. 1.35. What is the difference between the Imports(as % of merchandise exports) in Middle East & North Africa (all income levels) in 2000 and the Imports(as % of merchandise exports) in Belarus in 2002?
Offer a very short reply. -0.68. What is the difference between the Imports(as % of merchandise exports) of Middle East & North Africa (all income levels) in 2000 and the Imports(as % of merchandise exports) of Estonia in 2002?
Ensure brevity in your answer.  -1.32. What is the difference between the Imports(as % of merchandise exports) in Middle East & North Africa (all income levels) in 2000 and the Imports(as % of merchandise exports) in Ghana in 2002?
Your answer should be compact. -0.25. What is the difference between the Imports(as % of merchandise exports) in Belarus in 2000 and the Imports(as % of merchandise exports) in Estonia in 2002?
Your response must be concise. -0.6. What is the difference between the Imports(as % of merchandise exports) of Belarus in 2000 and the Imports(as % of merchandise exports) of Ghana in 2002?
Offer a terse response. 0.48. What is the difference between the Imports(as % of merchandise exports) in Estonia in 2000 and the Imports(as % of merchandise exports) in Ghana in 2002?
Provide a succinct answer. 1.44. What is the difference between the Imports(as % of merchandise exports) of Middle East & North Africa (all income levels) in 2000 and the Imports(as % of merchandise exports) of Belarus in 2003?
Provide a succinct answer. -0.57. What is the difference between the Imports(as % of merchandise exports) in Middle East & North Africa (all income levels) in 2000 and the Imports(as % of merchandise exports) in Estonia in 2003?
Provide a short and direct response. -1.5. What is the difference between the Imports(as % of merchandise exports) in Middle East & North Africa (all income levels) in 2000 and the Imports(as % of merchandise exports) in Ghana in 2003?
Keep it short and to the point. -0.07. What is the difference between the Imports(as % of merchandise exports) in Belarus in 2000 and the Imports(as % of merchandise exports) in Estonia in 2003?
Provide a succinct answer. -0.77. What is the difference between the Imports(as % of merchandise exports) of Belarus in 2000 and the Imports(as % of merchandise exports) of Ghana in 2003?
Your answer should be compact. 0.65. What is the difference between the Imports(as % of merchandise exports) in Estonia in 2000 and the Imports(as % of merchandise exports) in Ghana in 2003?
Your answer should be very brief. 1.61. What is the difference between the Imports(as % of merchandise exports) of Middle East & North Africa (all income levels) in 2000 and the Imports(as % of merchandise exports) of Belarus in 2005?
Offer a very short reply. -0.1. What is the difference between the Imports(as % of merchandise exports) in Middle East & North Africa (all income levels) in 2000 and the Imports(as % of merchandise exports) in Estonia in 2005?
Your response must be concise. -1.59. What is the difference between the Imports(as % of merchandise exports) in Middle East & North Africa (all income levels) in 2000 and the Imports(as % of merchandise exports) in Ghana in 2005?
Offer a very short reply. 0.48. What is the difference between the Imports(as % of merchandise exports) in Belarus in 2000 and the Imports(as % of merchandise exports) in Estonia in 2005?
Your response must be concise. -0.87. What is the difference between the Imports(as % of merchandise exports) in Belarus in 2000 and the Imports(as % of merchandise exports) in Ghana in 2005?
Your response must be concise. 1.2. What is the difference between the Imports(as % of merchandise exports) of Estonia in 2000 and the Imports(as % of merchandise exports) of Ghana in 2005?
Your answer should be compact. 2.17. What is the difference between the Imports(as % of merchandise exports) in Middle East & North Africa (all income levels) in 2000 and the Imports(as % of merchandise exports) in Belarus in 2006?
Your response must be concise. 0.06. What is the difference between the Imports(as % of merchandise exports) of Middle East & North Africa (all income levels) in 2000 and the Imports(as % of merchandise exports) of Estonia in 2006?
Your response must be concise. -0.95. What is the difference between the Imports(as % of merchandise exports) of Middle East & North Africa (all income levels) in 2000 and the Imports(as % of merchandise exports) of Ghana in 2006?
Provide a short and direct response. 0.37. What is the difference between the Imports(as % of merchandise exports) in Belarus in 2000 and the Imports(as % of merchandise exports) in Estonia in 2006?
Ensure brevity in your answer.  -0.23. What is the difference between the Imports(as % of merchandise exports) of Belarus in 2000 and the Imports(as % of merchandise exports) of Ghana in 2006?
Ensure brevity in your answer.  1.09. What is the difference between the Imports(as % of merchandise exports) of Estonia in 2000 and the Imports(as % of merchandise exports) of Ghana in 2006?
Give a very brief answer. 2.06. What is the difference between the Imports(as % of merchandise exports) in Middle East & North Africa (all income levels) in 2001 and the Imports(as % of merchandise exports) in Belarus in 2002?
Your answer should be very brief. -0.77. What is the difference between the Imports(as % of merchandise exports) in Middle East & North Africa (all income levels) in 2001 and the Imports(as % of merchandise exports) in Estonia in 2002?
Your response must be concise. -1.41. What is the difference between the Imports(as % of merchandise exports) in Middle East & North Africa (all income levels) in 2001 and the Imports(as % of merchandise exports) in Ghana in 2002?
Offer a terse response. -0.34. What is the difference between the Imports(as % of merchandise exports) in Belarus in 2001 and the Imports(as % of merchandise exports) in Estonia in 2002?
Provide a short and direct response. -0.59. What is the difference between the Imports(as % of merchandise exports) in Belarus in 2001 and the Imports(as % of merchandise exports) in Ghana in 2002?
Offer a very short reply. 0.49. What is the difference between the Imports(as % of merchandise exports) of Estonia in 2001 and the Imports(as % of merchandise exports) of Ghana in 2002?
Your response must be concise. 1.23. What is the difference between the Imports(as % of merchandise exports) in Middle East & North Africa (all income levels) in 2001 and the Imports(as % of merchandise exports) in Belarus in 2003?
Your answer should be compact. -0.66. What is the difference between the Imports(as % of merchandise exports) of Middle East & North Africa (all income levels) in 2001 and the Imports(as % of merchandise exports) of Estonia in 2003?
Your response must be concise. -1.59. What is the difference between the Imports(as % of merchandise exports) in Middle East & North Africa (all income levels) in 2001 and the Imports(as % of merchandise exports) in Ghana in 2003?
Ensure brevity in your answer.  -0.16. What is the difference between the Imports(as % of merchandise exports) in Belarus in 2001 and the Imports(as % of merchandise exports) in Estonia in 2003?
Your answer should be compact. -0.76. What is the difference between the Imports(as % of merchandise exports) in Belarus in 2001 and the Imports(as % of merchandise exports) in Ghana in 2003?
Your response must be concise. 0.66. What is the difference between the Imports(as % of merchandise exports) of Estonia in 2001 and the Imports(as % of merchandise exports) of Ghana in 2003?
Give a very brief answer. 1.41. What is the difference between the Imports(as % of merchandise exports) of Middle East & North Africa (all income levels) in 2001 and the Imports(as % of merchandise exports) of Belarus in 2005?
Keep it short and to the point. -0.19. What is the difference between the Imports(as % of merchandise exports) in Middle East & North Africa (all income levels) in 2001 and the Imports(as % of merchandise exports) in Estonia in 2005?
Make the answer very short. -1.68. What is the difference between the Imports(as % of merchandise exports) in Middle East & North Africa (all income levels) in 2001 and the Imports(as % of merchandise exports) in Ghana in 2005?
Provide a succinct answer. 0.39. What is the difference between the Imports(as % of merchandise exports) in Belarus in 2001 and the Imports(as % of merchandise exports) in Estonia in 2005?
Offer a very short reply. -0.86. What is the difference between the Imports(as % of merchandise exports) of Belarus in 2001 and the Imports(as % of merchandise exports) of Ghana in 2005?
Provide a short and direct response. 1.21. What is the difference between the Imports(as % of merchandise exports) in Estonia in 2001 and the Imports(as % of merchandise exports) in Ghana in 2005?
Make the answer very short. 1.96. What is the difference between the Imports(as % of merchandise exports) in Middle East & North Africa (all income levels) in 2001 and the Imports(as % of merchandise exports) in Belarus in 2006?
Keep it short and to the point. -0.03. What is the difference between the Imports(as % of merchandise exports) in Middle East & North Africa (all income levels) in 2001 and the Imports(as % of merchandise exports) in Estonia in 2006?
Give a very brief answer. -1.04. What is the difference between the Imports(as % of merchandise exports) in Middle East & North Africa (all income levels) in 2001 and the Imports(as % of merchandise exports) in Ghana in 2006?
Provide a succinct answer. 0.28. What is the difference between the Imports(as % of merchandise exports) in Belarus in 2001 and the Imports(as % of merchandise exports) in Estonia in 2006?
Offer a terse response. -0.22. What is the difference between the Imports(as % of merchandise exports) in Belarus in 2001 and the Imports(as % of merchandise exports) in Ghana in 2006?
Your response must be concise. 1.11. What is the difference between the Imports(as % of merchandise exports) of Estonia in 2001 and the Imports(as % of merchandise exports) of Ghana in 2006?
Keep it short and to the point. 1.85. What is the difference between the Imports(as % of merchandise exports) in Middle East & North Africa (all income levels) in 2002 and the Imports(as % of merchandise exports) in Belarus in 2003?
Provide a succinct answer. -0.52. What is the difference between the Imports(as % of merchandise exports) in Middle East & North Africa (all income levels) in 2002 and the Imports(as % of merchandise exports) in Estonia in 2003?
Give a very brief answer. -1.44. What is the difference between the Imports(as % of merchandise exports) of Middle East & North Africa (all income levels) in 2002 and the Imports(as % of merchandise exports) of Ghana in 2003?
Your answer should be compact. -0.02. What is the difference between the Imports(as % of merchandise exports) of Belarus in 2002 and the Imports(as % of merchandise exports) of Estonia in 2003?
Give a very brief answer. -0.82. What is the difference between the Imports(as % of merchandise exports) of Belarus in 2002 and the Imports(as % of merchandise exports) of Ghana in 2003?
Your response must be concise. 0.6. What is the difference between the Imports(as % of merchandise exports) in Estonia in 2002 and the Imports(as % of merchandise exports) in Ghana in 2003?
Your answer should be compact. 1.25. What is the difference between the Imports(as % of merchandise exports) in Middle East & North Africa (all income levels) in 2002 and the Imports(as % of merchandise exports) in Belarus in 2005?
Offer a very short reply. -0.05. What is the difference between the Imports(as % of merchandise exports) of Middle East & North Africa (all income levels) in 2002 and the Imports(as % of merchandise exports) of Estonia in 2005?
Your response must be concise. -1.54. What is the difference between the Imports(as % of merchandise exports) of Middle East & North Africa (all income levels) in 2002 and the Imports(as % of merchandise exports) of Ghana in 2005?
Your answer should be very brief. 0.53. What is the difference between the Imports(as % of merchandise exports) in Belarus in 2002 and the Imports(as % of merchandise exports) in Estonia in 2005?
Your answer should be compact. -0.92. What is the difference between the Imports(as % of merchandise exports) of Belarus in 2002 and the Imports(as % of merchandise exports) of Ghana in 2005?
Provide a succinct answer. 1.16. What is the difference between the Imports(as % of merchandise exports) of Estonia in 2002 and the Imports(as % of merchandise exports) of Ghana in 2005?
Ensure brevity in your answer.  1.8. What is the difference between the Imports(as % of merchandise exports) in Middle East & North Africa (all income levels) in 2002 and the Imports(as % of merchandise exports) in Belarus in 2006?
Your answer should be compact. 0.11. What is the difference between the Imports(as % of merchandise exports) in Middle East & North Africa (all income levels) in 2002 and the Imports(as % of merchandise exports) in Estonia in 2006?
Your answer should be compact. -0.89. What is the difference between the Imports(as % of merchandise exports) of Middle East & North Africa (all income levels) in 2002 and the Imports(as % of merchandise exports) of Ghana in 2006?
Provide a short and direct response. 0.43. What is the difference between the Imports(as % of merchandise exports) of Belarus in 2002 and the Imports(as % of merchandise exports) of Estonia in 2006?
Make the answer very short. -0.27. What is the difference between the Imports(as % of merchandise exports) of Belarus in 2002 and the Imports(as % of merchandise exports) of Ghana in 2006?
Give a very brief answer. 1.05. What is the difference between the Imports(as % of merchandise exports) of Estonia in 2002 and the Imports(as % of merchandise exports) of Ghana in 2006?
Your answer should be very brief. 1.7. What is the difference between the Imports(as % of merchandise exports) of Middle East & North Africa (all income levels) in 2003 and the Imports(as % of merchandise exports) of Belarus in 2005?
Ensure brevity in your answer.  0.09. What is the difference between the Imports(as % of merchandise exports) of Middle East & North Africa (all income levels) in 2003 and the Imports(as % of merchandise exports) of Estonia in 2005?
Offer a very short reply. -1.4. What is the difference between the Imports(as % of merchandise exports) of Middle East & North Africa (all income levels) in 2003 and the Imports(as % of merchandise exports) of Ghana in 2005?
Offer a very short reply. 0.67. What is the difference between the Imports(as % of merchandise exports) of Belarus in 2003 and the Imports(as % of merchandise exports) of Estonia in 2005?
Keep it short and to the point. -1.02. What is the difference between the Imports(as % of merchandise exports) of Belarus in 2003 and the Imports(as % of merchandise exports) of Ghana in 2005?
Give a very brief answer. 1.05. What is the difference between the Imports(as % of merchandise exports) in Estonia in 2003 and the Imports(as % of merchandise exports) in Ghana in 2005?
Offer a terse response. 1.98. What is the difference between the Imports(as % of merchandise exports) in Middle East & North Africa (all income levels) in 2003 and the Imports(as % of merchandise exports) in Belarus in 2006?
Make the answer very short. 0.25. What is the difference between the Imports(as % of merchandise exports) in Middle East & North Africa (all income levels) in 2003 and the Imports(as % of merchandise exports) in Estonia in 2006?
Your answer should be very brief. -0.76. What is the difference between the Imports(as % of merchandise exports) in Middle East & North Africa (all income levels) in 2003 and the Imports(as % of merchandise exports) in Ghana in 2006?
Provide a short and direct response. 0.56. What is the difference between the Imports(as % of merchandise exports) of Belarus in 2003 and the Imports(as % of merchandise exports) of Estonia in 2006?
Your answer should be compact. -0.38. What is the difference between the Imports(as % of merchandise exports) of Belarus in 2003 and the Imports(as % of merchandise exports) of Ghana in 2006?
Your answer should be very brief. 0.94. What is the difference between the Imports(as % of merchandise exports) of Estonia in 2003 and the Imports(as % of merchandise exports) of Ghana in 2006?
Ensure brevity in your answer.  1.87. What is the difference between the Imports(as % of merchandise exports) in Middle East & North Africa (all income levels) in 2005 and the Imports(as % of merchandise exports) in Belarus in 2006?
Your answer should be very brief. -0.12. What is the difference between the Imports(as % of merchandise exports) in Middle East & North Africa (all income levels) in 2005 and the Imports(as % of merchandise exports) in Estonia in 2006?
Offer a terse response. -1.12. What is the difference between the Imports(as % of merchandise exports) in Middle East & North Africa (all income levels) in 2005 and the Imports(as % of merchandise exports) in Ghana in 2006?
Your response must be concise. 0.2. What is the difference between the Imports(as % of merchandise exports) of Belarus in 2005 and the Imports(as % of merchandise exports) of Estonia in 2006?
Ensure brevity in your answer.  -0.85. What is the difference between the Imports(as % of merchandise exports) in Belarus in 2005 and the Imports(as % of merchandise exports) in Ghana in 2006?
Provide a short and direct response. 0.47. What is the difference between the Imports(as % of merchandise exports) in Estonia in 2005 and the Imports(as % of merchandise exports) in Ghana in 2006?
Give a very brief answer. 1.97. What is the average Imports(as % of merchandise exports) of Middle East & North Africa (all income levels) per year?
Keep it short and to the point. 1.61. What is the average Imports(as % of merchandise exports) of Belarus per year?
Offer a terse response. 2.17. What is the average Imports(as % of merchandise exports) of Estonia per year?
Keep it short and to the point. 2.93. What is the average Imports(as % of merchandise exports) in Ghana per year?
Ensure brevity in your answer.  1.96. In the year 1998, what is the difference between the Imports(as % of merchandise exports) in Middle East & North Africa (all income levels) and Imports(as % of merchandise exports) in Belarus?
Give a very brief answer. -0.45. In the year 1998, what is the difference between the Imports(as % of merchandise exports) of Middle East & North Africa (all income levels) and Imports(as % of merchandise exports) of Estonia?
Keep it short and to the point. -0.52. In the year 1998, what is the difference between the Imports(as % of merchandise exports) of Middle East & North Africa (all income levels) and Imports(as % of merchandise exports) of Ghana?
Ensure brevity in your answer.  -0.97. In the year 1998, what is the difference between the Imports(as % of merchandise exports) in Belarus and Imports(as % of merchandise exports) in Estonia?
Provide a succinct answer. -0.07. In the year 1998, what is the difference between the Imports(as % of merchandise exports) of Belarus and Imports(as % of merchandise exports) of Ghana?
Your response must be concise. -0.52. In the year 1998, what is the difference between the Imports(as % of merchandise exports) in Estonia and Imports(as % of merchandise exports) in Ghana?
Make the answer very short. -0.45. In the year 1999, what is the difference between the Imports(as % of merchandise exports) in Middle East & North Africa (all income levels) and Imports(as % of merchandise exports) in Belarus?
Your response must be concise. -1.02. In the year 1999, what is the difference between the Imports(as % of merchandise exports) of Middle East & North Africa (all income levels) and Imports(as % of merchandise exports) of Estonia?
Your answer should be compact. -1.26. In the year 1999, what is the difference between the Imports(as % of merchandise exports) of Middle East & North Africa (all income levels) and Imports(as % of merchandise exports) of Ghana?
Make the answer very short. -1.02. In the year 1999, what is the difference between the Imports(as % of merchandise exports) of Belarus and Imports(as % of merchandise exports) of Estonia?
Provide a succinct answer. -0.24. In the year 1999, what is the difference between the Imports(as % of merchandise exports) of Belarus and Imports(as % of merchandise exports) of Ghana?
Your answer should be compact. 0. In the year 1999, what is the difference between the Imports(as % of merchandise exports) of Estonia and Imports(as % of merchandise exports) of Ghana?
Make the answer very short. 0.24. In the year 2000, what is the difference between the Imports(as % of merchandise exports) in Middle East & North Africa (all income levels) and Imports(as % of merchandise exports) in Belarus?
Your response must be concise. -0.72. In the year 2000, what is the difference between the Imports(as % of merchandise exports) of Middle East & North Africa (all income levels) and Imports(as % of merchandise exports) of Estonia?
Your response must be concise. -1.69. In the year 2000, what is the difference between the Imports(as % of merchandise exports) of Middle East & North Africa (all income levels) and Imports(as % of merchandise exports) of Ghana?
Provide a succinct answer. -0.81. In the year 2000, what is the difference between the Imports(as % of merchandise exports) of Belarus and Imports(as % of merchandise exports) of Estonia?
Your answer should be compact. -0.96. In the year 2000, what is the difference between the Imports(as % of merchandise exports) in Belarus and Imports(as % of merchandise exports) in Ghana?
Provide a short and direct response. -0.08. In the year 2000, what is the difference between the Imports(as % of merchandise exports) of Estonia and Imports(as % of merchandise exports) of Ghana?
Your answer should be very brief. 0.88. In the year 2001, what is the difference between the Imports(as % of merchandise exports) of Middle East & North Africa (all income levels) and Imports(as % of merchandise exports) of Belarus?
Your answer should be very brief. -0.82. In the year 2001, what is the difference between the Imports(as % of merchandise exports) of Middle East & North Africa (all income levels) and Imports(as % of merchandise exports) of Estonia?
Give a very brief answer. -1.57. In the year 2001, what is the difference between the Imports(as % of merchandise exports) of Middle East & North Africa (all income levels) and Imports(as % of merchandise exports) of Ghana?
Give a very brief answer. -0.42. In the year 2001, what is the difference between the Imports(as % of merchandise exports) of Belarus and Imports(as % of merchandise exports) of Estonia?
Keep it short and to the point. -0.75. In the year 2001, what is the difference between the Imports(as % of merchandise exports) in Estonia and Imports(as % of merchandise exports) in Ghana?
Your answer should be compact. 1.15. In the year 2002, what is the difference between the Imports(as % of merchandise exports) in Middle East & North Africa (all income levels) and Imports(as % of merchandise exports) in Belarus?
Offer a very short reply. -0.62. In the year 2002, what is the difference between the Imports(as % of merchandise exports) of Middle East & North Africa (all income levels) and Imports(as % of merchandise exports) of Estonia?
Offer a very short reply. -1.27. In the year 2002, what is the difference between the Imports(as % of merchandise exports) in Middle East & North Africa (all income levels) and Imports(as % of merchandise exports) in Ghana?
Make the answer very short. -0.19. In the year 2002, what is the difference between the Imports(as % of merchandise exports) of Belarus and Imports(as % of merchandise exports) of Estonia?
Provide a short and direct response. -0.65. In the year 2002, what is the difference between the Imports(as % of merchandise exports) in Belarus and Imports(as % of merchandise exports) in Ghana?
Your response must be concise. 0.43. In the year 2002, what is the difference between the Imports(as % of merchandise exports) of Estonia and Imports(as % of merchandise exports) of Ghana?
Offer a very short reply. 1.08. In the year 2003, what is the difference between the Imports(as % of merchandise exports) in Middle East & North Africa (all income levels) and Imports(as % of merchandise exports) in Belarus?
Give a very brief answer. -0.38. In the year 2003, what is the difference between the Imports(as % of merchandise exports) in Middle East & North Africa (all income levels) and Imports(as % of merchandise exports) in Estonia?
Offer a terse response. -1.3. In the year 2003, what is the difference between the Imports(as % of merchandise exports) in Middle East & North Africa (all income levels) and Imports(as % of merchandise exports) in Ghana?
Offer a terse response. 0.12. In the year 2003, what is the difference between the Imports(as % of merchandise exports) in Belarus and Imports(as % of merchandise exports) in Estonia?
Give a very brief answer. -0.93. In the year 2003, what is the difference between the Imports(as % of merchandise exports) in Belarus and Imports(as % of merchandise exports) in Ghana?
Make the answer very short. 0.5. In the year 2003, what is the difference between the Imports(as % of merchandise exports) in Estonia and Imports(as % of merchandise exports) in Ghana?
Give a very brief answer. 1.42. In the year 2005, what is the difference between the Imports(as % of merchandise exports) in Middle East & North Africa (all income levels) and Imports(as % of merchandise exports) in Belarus?
Ensure brevity in your answer.  -0.28. In the year 2005, what is the difference between the Imports(as % of merchandise exports) of Middle East & North Africa (all income levels) and Imports(as % of merchandise exports) of Estonia?
Keep it short and to the point. -1.77. In the year 2005, what is the difference between the Imports(as % of merchandise exports) of Middle East & North Africa (all income levels) and Imports(as % of merchandise exports) of Ghana?
Give a very brief answer. 0.31. In the year 2005, what is the difference between the Imports(as % of merchandise exports) of Belarus and Imports(as % of merchandise exports) of Estonia?
Provide a short and direct response. -1.49. In the year 2005, what is the difference between the Imports(as % of merchandise exports) in Belarus and Imports(as % of merchandise exports) in Ghana?
Your response must be concise. 0.58. In the year 2005, what is the difference between the Imports(as % of merchandise exports) in Estonia and Imports(as % of merchandise exports) in Ghana?
Offer a very short reply. 2.07. In the year 2006, what is the difference between the Imports(as % of merchandise exports) of Middle East & North Africa (all income levels) and Imports(as % of merchandise exports) of Belarus?
Give a very brief answer. -0.15. In the year 2006, what is the difference between the Imports(as % of merchandise exports) of Middle East & North Africa (all income levels) and Imports(as % of merchandise exports) of Estonia?
Make the answer very short. -1.15. In the year 2006, what is the difference between the Imports(as % of merchandise exports) in Middle East & North Africa (all income levels) and Imports(as % of merchandise exports) in Ghana?
Provide a short and direct response. 0.17. In the year 2006, what is the difference between the Imports(as % of merchandise exports) of Belarus and Imports(as % of merchandise exports) of Estonia?
Your answer should be very brief. -1.01. In the year 2006, what is the difference between the Imports(as % of merchandise exports) of Belarus and Imports(as % of merchandise exports) of Ghana?
Make the answer very short. 0.31. In the year 2006, what is the difference between the Imports(as % of merchandise exports) in Estonia and Imports(as % of merchandise exports) in Ghana?
Ensure brevity in your answer.  1.32. What is the ratio of the Imports(as % of merchandise exports) of Middle East & North Africa (all income levels) in 1998 to that in 1999?
Keep it short and to the point. 1.19. What is the ratio of the Imports(as % of merchandise exports) in Belarus in 1998 to that in 1999?
Keep it short and to the point. 0.91. What is the ratio of the Imports(as % of merchandise exports) of Estonia in 1998 to that in 1999?
Keep it short and to the point. 0.86. What is the ratio of the Imports(as % of merchandise exports) in Ghana in 1998 to that in 1999?
Ensure brevity in your answer.  1.1. What is the ratio of the Imports(as % of merchandise exports) of Middle East & North Africa (all income levels) in 1998 to that in 2000?
Keep it short and to the point. 1.25. What is the ratio of the Imports(as % of merchandise exports) of Belarus in 1998 to that in 2000?
Make the answer very short. 1.06. What is the ratio of the Imports(as % of merchandise exports) in Estonia in 1998 to that in 2000?
Offer a terse response. 0.76. What is the ratio of the Imports(as % of merchandise exports) in Ghana in 1998 to that in 2000?
Provide a short and direct response. 1.24. What is the ratio of the Imports(as % of merchandise exports) of Middle East & North Africa (all income levels) in 1998 to that in 2001?
Make the answer very short. 1.33. What is the ratio of the Imports(as % of merchandise exports) of Belarus in 1998 to that in 2001?
Ensure brevity in your answer.  1.05. What is the ratio of the Imports(as % of merchandise exports) in Estonia in 1998 to that in 2001?
Provide a succinct answer. 0.82. What is the ratio of the Imports(as % of merchandise exports) in Ghana in 1998 to that in 2001?
Offer a terse response. 1.54. What is the ratio of the Imports(as % of merchandise exports) in Middle East & North Africa (all income levels) in 1998 to that in 2002?
Give a very brief answer. 1.21. What is the ratio of the Imports(as % of merchandise exports) in Belarus in 1998 to that in 2002?
Your answer should be very brief. 1.08. What is the ratio of the Imports(as % of merchandise exports) in Estonia in 1998 to that in 2002?
Your response must be concise. 0.86. What is the ratio of the Imports(as % of merchandise exports) in Ghana in 1998 to that in 2002?
Your response must be concise. 1.62. What is the ratio of the Imports(as % of merchandise exports) in Middle East & North Africa (all income levels) in 1998 to that in 2003?
Ensure brevity in your answer.  1.12. What is the ratio of the Imports(as % of merchandise exports) in Belarus in 1998 to that in 2003?
Offer a terse response. 1.13. What is the ratio of the Imports(as % of merchandise exports) in Estonia in 1998 to that in 2003?
Your answer should be very brief. 0.81. What is the ratio of the Imports(as % of merchandise exports) of Ghana in 1998 to that in 2003?
Give a very brief answer. 1.79. What is the ratio of the Imports(as % of merchandise exports) in Middle East & North Africa (all income levels) in 1998 to that in 2005?
Give a very brief answer. 1.41. What is the ratio of the Imports(as % of merchandise exports) of Belarus in 1998 to that in 2005?
Keep it short and to the point. 1.45. What is the ratio of the Imports(as % of merchandise exports) of Estonia in 1998 to that in 2005?
Provide a short and direct response. 0.79. What is the ratio of the Imports(as % of merchandise exports) in Ghana in 1998 to that in 2005?
Keep it short and to the point. 2.69. What is the ratio of the Imports(as % of merchandise exports) of Middle East & North Africa (all income levels) in 1998 to that in 2006?
Give a very brief answer. 1.44. What is the ratio of the Imports(as % of merchandise exports) in Belarus in 1998 to that in 2006?
Provide a succinct answer. 1.6. What is the ratio of the Imports(as % of merchandise exports) of Estonia in 1998 to that in 2006?
Keep it short and to the point. 0.99. What is the ratio of the Imports(as % of merchandise exports) of Ghana in 1998 to that in 2006?
Your answer should be very brief. 2.45. What is the ratio of the Imports(as % of merchandise exports) in Middle East & North Africa (all income levels) in 1999 to that in 2000?
Provide a short and direct response. 1.05. What is the ratio of the Imports(as % of merchandise exports) in Belarus in 1999 to that in 2000?
Provide a short and direct response. 1.16. What is the ratio of the Imports(as % of merchandise exports) of Estonia in 1999 to that in 2000?
Give a very brief answer. 0.89. What is the ratio of the Imports(as % of merchandise exports) of Ghana in 1999 to that in 2000?
Provide a succinct answer. 1.12. What is the ratio of the Imports(as % of merchandise exports) in Middle East & North Africa (all income levels) in 1999 to that in 2001?
Offer a terse response. 1.11. What is the ratio of the Imports(as % of merchandise exports) in Belarus in 1999 to that in 2001?
Give a very brief answer. 1.16. What is the ratio of the Imports(as % of merchandise exports) of Estonia in 1999 to that in 2001?
Your answer should be very brief. 0.95. What is the ratio of the Imports(as % of merchandise exports) in Ghana in 1999 to that in 2001?
Ensure brevity in your answer.  1.4. What is the ratio of the Imports(as % of merchandise exports) of Middle East & North Africa (all income levels) in 1999 to that in 2002?
Your response must be concise. 1.01. What is the ratio of the Imports(as % of merchandise exports) of Belarus in 1999 to that in 2002?
Your answer should be compact. 1.19. What is the ratio of the Imports(as % of merchandise exports) of Ghana in 1999 to that in 2002?
Give a very brief answer. 1.47. What is the ratio of the Imports(as % of merchandise exports) of Middle East & North Africa (all income levels) in 1999 to that in 2003?
Offer a terse response. 0.94. What is the ratio of the Imports(as % of merchandise exports) in Belarus in 1999 to that in 2003?
Give a very brief answer. 1.25. What is the ratio of the Imports(as % of merchandise exports) in Estonia in 1999 to that in 2003?
Your answer should be compact. 0.95. What is the ratio of the Imports(as % of merchandise exports) in Ghana in 1999 to that in 2003?
Your response must be concise. 1.62. What is the ratio of the Imports(as % of merchandise exports) of Middle East & North Africa (all income levels) in 1999 to that in 2005?
Ensure brevity in your answer.  1.18. What is the ratio of the Imports(as % of merchandise exports) of Belarus in 1999 to that in 2005?
Your answer should be compact. 1.59. What is the ratio of the Imports(as % of merchandise exports) of Estonia in 1999 to that in 2005?
Ensure brevity in your answer.  0.92. What is the ratio of the Imports(as % of merchandise exports) of Ghana in 1999 to that in 2005?
Make the answer very short. 2.43. What is the ratio of the Imports(as % of merchandise exports) in Middle East & North Africa (all income levels) in 1999 to that in 2006?
Offer a very short reply. 1.21. What is the ratio of the Imports(as % of merchandise exports) in Belarus in 1999 to that in 2006?
Ensure brevity in your answer.  1.76. What is the ratio of the Imports(as % of merchandise exports) of Estonia in 1999 to that in 2006?
Offer a very short reply. 1.16. What is the ratio of the Imports(as % of merchandise exports) in Ghana in 1999 to that in 2006?
Make the answer very short. 2.22. What is the ratio of the Imports(as % of merchandise exports) in Middle East & North Africa (all income levels) in 2000 to that in 2001?
Make the answer very short. 1.06. What is the ratio of the Imports(as % of merchandise exports) in Belarus in 2000 to that in 2001?
Provide a short and direct response. 1. What is the ratio of the Imports(as % of merchandise exports) in Estonia in 2000 to that in 2001?
Make the answer very short. 1.07. What is the ratio of the Imports(as % of merchandise exports) in Ghana in 2000 to that in 2001?
Ensure brevity in your answer.  1.25. What is the ratio of the Imports(as % of merchandise exports) in Middle East & North Africa (all income levels) in 2000 to that in 2002?
Offer a terse response. 0.97. What is the ratio of the Imports(as % of merchandise exports) of Belarus in 2000 to that in 2002?
Your response must be concise. 1.02. What is the ratio of the Imports(as % of merchandise exports) of Estonia in 2000 to that in 2002?
Keep it short and to the point. 1.12. What is the ratio of the Imports(as % of merchandise exports) of Ghana in 2000 to that in 2002?
Offer a very short reply. 1.31. What is the ratio of the Imports(as % of merchandise exports) of Middle East & North Africa (all income levels) in 2000 to that in 2003?
Provide a succinct answer. 0.89. What is the ratio of the Imports(as % of merchandise exports) of Belarus in 2000 to that in 2003?
Keep it short and to the point. 1.07. What is the ratio of the Imports(as % of merchandise exports) in Estonia in 2000 to that in 2003?
Your answer should be compact. 1.06. What is the ratio of the Imports(as % of merchandise exports) of Ghana in 2000 to that in 2003?
Your response must be concise. 1.44. What is the ratio of the Imports(as % of merchandise exports) in Middle East & North Africa (all income levels) in 2000 to that in 2005?
Your response must be concise. 1.12. What is the ratio of the Imports(as % of merchandise exports) of Belarus in 2000 to that in 2005?
Your response must be concise. 1.37. What is the ratio of the Imports(as % of merchandise exports) of Estonia in 2000 to that in 2005?
Your answer should be very brief. 1.03. What is the ratio of the Imports(as % of merchandise exports) in Ghana in 2000 to that in 2005?
Offer a very short reply. 2.17. What is the ratio of the Imports(as % of merchandise exports) of Middle East & North Africa (all income levels) in 2000 to that in 2006?
Keep it short and to the point. 1.15. What is the ratio of the Imports(as % of merchandise exports) of Belarus in 2000 to that in 2006?
Give a very brief answer. 1.51. What is the ratio of the Imports(as % of merchandise exports) in Estonia in 2000 to that in 2006?
Provide a succinct answer. 1.29. What is the ratio of the Imports(as % of merchandise exports) of Ghana in 2000 to that in 2006?
Provide a succinct answer. 1.98. What is the ratio of the Imports(as % of merchandise exports) in Middle East & North Africa (all income levels) in 2001 to that in 2002?
Offer a terse response. 0.91. What is the ratio of the Imports(as % of merchandise exports) of Belarus in 2001 to that in 2002?
Make the answer very short. 1.03. What is the ratio of the Imports(as % of merchandise exports) of Estonia in 2001 to that in 2002?
Keep it short and to the point. 1.05. What is the ratio of the Imports(as % of merchandise exports) of Ghana in 2001 to that in 2002?
Offer a terse response. 1.05. What is the ratio of the Imports(as % of merchandise exports) in Middle East & North Africa (all income levels) in 2001 to that in 2003?
Provide a succinct answer. 0.84. What is the ratio of the Imports(as % of merchandise exports) of Belarus in 2001 to that in 2003?
Provide a succinct answer. 1.08. What is the ratio of the Imports(as % of merchandise exports) of Estonia in 2001 to that in 2003?
Make the answer very short. 1. What is the ratio of the Imports(as % of merchandise exports) of Ghana in 2001 to that in 2003?
Your answer should be compact. 1.16. What is the ratio of the Imports(as % of merchandise exports) of Middle East & North Africa (all income levels) in 2001 to that in 2005?
Offer a terse response. 1.06. What is the ratio of the Imports(as % of merchandise exports) of Belarus in 2001 to that in 2005?
Provide a short and direct response. 1.38. What is the ratio of the Imports(as % of merchandise exports) of Estonia in 2001 to that in 2005?
Provide a succinct answer. 0.96. What is the ratio of the Imports(as % of merchandise exports) in Ghana in 2001 to that in 2005?
Make the answer very short. 1.74. What is the ratio of the Imports(as % of merchandise exports) in Middle East & North Africa (all income levels) in 2001 to that in 2006?
Ensure brevity in your answer.  1.08. What is the ratio of the Imports(as % of merchandise exports) of Belarus in 2001 to that in 2006?
Offer a terse response. 1.52. What is the ratio of the Imports(as % of merchandise exports) in Estonia in 2001 to that in 2006?
Offer a terse response. 1.21. What is the ratio of the Imports(as % of merchandise exports) in Ghana in 2001 to that in 2006?
Make the answer very short. 1.58. What is the ratio of the Imports(as % of merchandise exports) in Middle East & North Africa (all income levels) in 2002 to that in 2003?
Make the answer very short. 0.92. What is the ratio of the Imports(as % of merchandise exports) in Belarus in 2002 to that in 2003?
Your answer should be very brief. 1.05. What is the ratio of the Imports(as % of merchandise exports) in Estonia in 2002 to that in 2003?
Make the answer very short. 0.94. What is the ratio of the Imports(as % of merchandise exports) in Ghana in 2002 to that in 2003?
Provide a short and direct response. 1.11. What is the ratio of the Imports(as % of merchandise exports) in Middle East & North Africa (all income levels) in 2002 to that in 2005?
Ensure brevity in your answer.  1.16. What is the ratio of the Imports(as % of merchandise exports) in Belarus in 2002 to that in 2005?
Your answer should be very brief. 1.34. What is the ratio of the Imports(as % of merchandise exports) in Estonia in 2002 to that in 2005?
Make the answer very short. 0.92. What is the ratio of the Imports(as % of merchandise exports) in Ghana in 2002 to that in 2005?
Give a very brief answer. 1.66. What is the ratio of the Imports(as % of merchandise exports) in Middle East & North Africa (all income levels) in 2002 to that in 2006?
Offer a terse response. 1.19. What is the ratio of the Imports(as % of merchandise exports) of Belarus in 2002 to that in 2006?
Your response must be concise. 1.48. What is the ratio of the Imports(as % of merchandise exports) in Estonia in 2002 to that in 2006?
Your answer should be compact. 1.15. What is the ratio of the Imports(as % of merchandise exports) in Ghana in 2002 to that in 2006?
Provide a short and direct response. 1.51. What is the ratio of the Imports(as % of merchandise exports) in Middle East & North Africa (all income levels) in 2003 to that in 2005?
Keep it short and to the point. 1.26. What is the ratio of the Imports(as % of merchandise exports) in Belarus in 2003 to that in 2005?
Provide a short and direct response. 1.28. What is the ratio of the Imports(as % of merchandise exports) of Estonia in 2003 to that in 2005?
Offer a terse response. 0.97. What is the ratio of the Imports(as % of merchandise exports) in Ghana in 2003 to that in 2005?
Your answer should be compact. 1.5. What is the ratio of the Imports(as % of merchandise exports) in Middle East & North Africa (all income levels) in 2003 to that in 2006?
Give a very brief answer. 1.29. What is the ratio of the Imports(as % of merchandise exports) in Belarus in 2003 to that in 2006?
Offer a very short reply. 1.41. What is the ratio of the Imports(as % of merchandise exports) of Estonia in 2003 to that in 2006?
Offer a terse response. 1.22. What is the ratio of the Imports(as % of merchandise exports) in Ghana in 2003 to that in 2006?
Offer a very short reply. 1.37. What is the ratio of the Imports(as % of merchandise exports) in Middle East & North Africa (all income levels) in 2005 to that in 2006?
Offer a terse response. 1.02. What is the ratio of the Imports(as % of merchandise exports) in Belarus in 2005 to that in 2006?
Make the answer very short. 1.1. What is the ratio of the Imports(as % of merchandise exports) of Estonia in 2005 to that in 2006?
Make the answer very short. 1.25. What is the ratio of the Imports(as % of merchandise exports) in Ghana in 2005 to that in 2006?
Make the answer very short. 0.91. What is the difference between the highest and the second highest Imports(as % of merchandise exports) of Middle East & North Africa (all income levels)?
Ensure brevity in your answer.  0.21. What is the difference between the highest and the second highest Imports(as % of merchandise exports) in Belarus?
Offer a very short reply. 0.25. What is the difference between the highest and the second highest Imports(as % of merchandise exports) in Estonia?
Offer a terse response. 0.09. What is the difference between the highest and the second highest Imports(as % of merchandise exports) of Ghana?
Provide a succinct answer. 0.28. What is the difference between the highest and the lowest Imports(as % of merchandise exports) of Middle East & North Africa (all income levels)?
Ensure brevity in your answer.  0.61. What is the difference between the highest and the lowest Imports(as % of merchandise exports) in Belarus?
Keep it short and to the point. 1.16. What is the difference between the highest and the lowest Imports(as % of merchandise exports) of Estonia?
Offer a terse response. 0.77. What is the difference between the highest and the lowest Imports(as % of merchandise exports) in Ghana?
Keep it short and to the point. 1.85. 